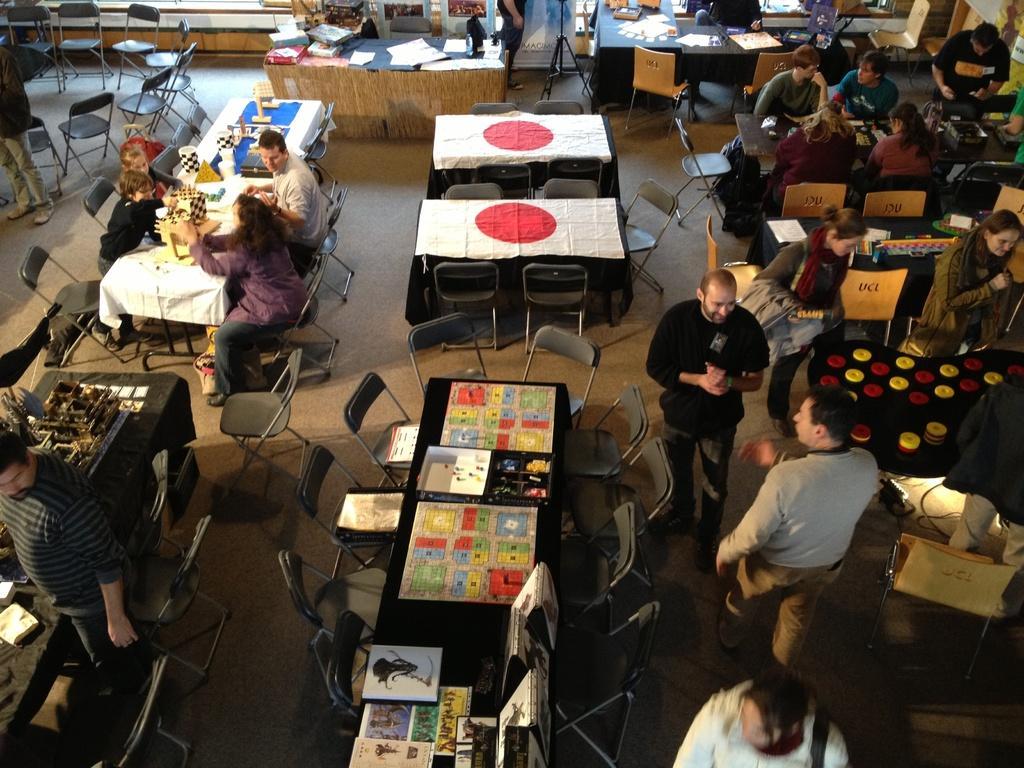Please provide a concise description of this image. there are so many people sitting on a chairs around the table. 